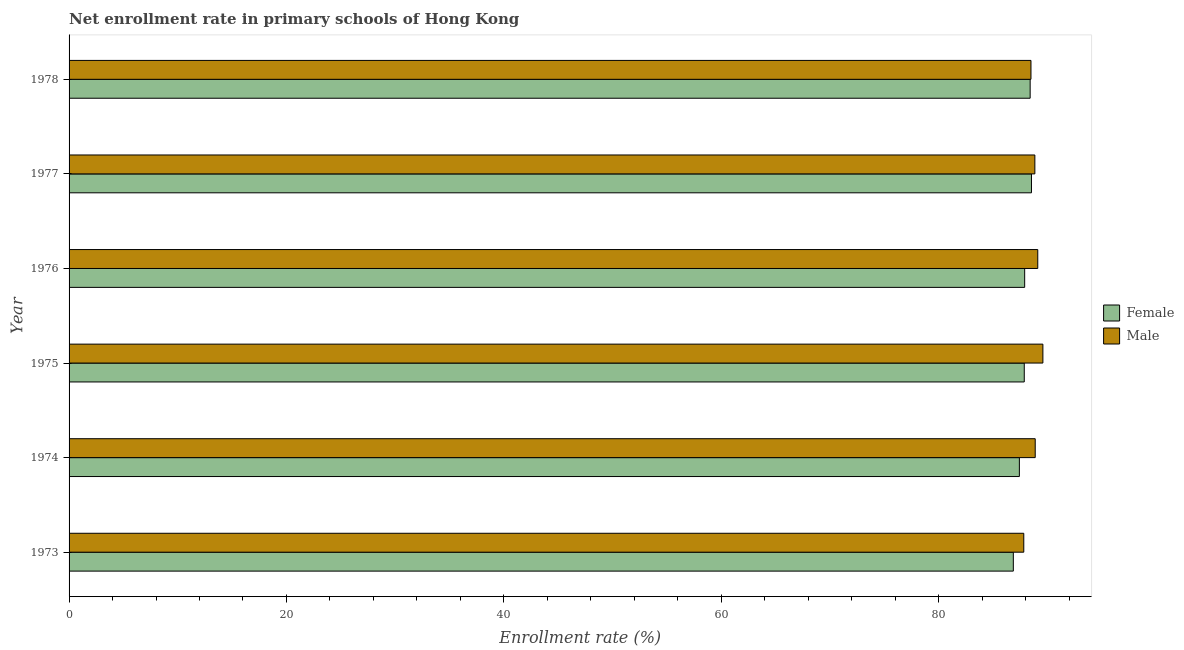How many different coloured bars are there?
Offer a very short reply. 2. How many groups of bars are there?
Give a very brief answer. 6. Are the number of bars per tick equal to the number of legend labels?
Your answer should be very brief. Yes. Are the number of bars on each tick of the Y-axis equal?
Your answer should be very brief. Yes. How many bars are there on the 6th tick from the top?
Offer a very short reply. 2. How many bars are there on the 2nd tick from the bottom?
Your answer should be very brief. 2. In how many cases, is the number of bars for a given year not equal to the number of legend labels?
Your response must be concise. 0. What is the enrollment rate of male students in 1973?
Ensure brevity in your answer.  87.83. Across all years, what is the maximum enrollment rate of female students?
Give a very brief answer. 88.54. Across all years, what is the minimum enrollment rate of female students?
Provide a short and direct response. 86.87. In which year was the enrollment rate of male students maximum?
Your response must be concise. 1975. What is the total enrollment rate of female students in the graph?
Give a very brief answer. 527.05. What is the difference between the enrollment rate of male students in 1974 and that in 1976?
Make the answer very short. -0.23. What is the difference between the enrollment rate of female students in 1975 and the enrollment rate of male students in 1978?
Provide a short and direct response. -0.62. What is the average enrollment rate of male students per year?
Your response must be concise. 88.8. Is the enrollment rate of male students in 1973 less than that in 1978?
Make the answer very short. Yes. What is the difference between the highest and the second highest enrollment rate of female students?
Your answer should be compact. 0.12. What is the difference between the highest and the lowest enrollment rate of male students?
Offer a terse response. 1.76. In how many years, is the enrollment rate of male students greater than the average enrollment rate of male students taken over all years?
Keep it short and to the point. 4. What does the 1st bar from the bottom in 1978 represents?
Offer a terse response. Female. Are all the bars in the graph horizontal?
Ensure brevity in your answer.  Yes. What is the difference between two consecutive major ticks on the X-axis?
Make the answer very short. 20. Are the values on the major ticks of X-axis written in scientific E-notation?
Your answer should be compact. No. Does the graph contain grids?
Provide a short and direct response. No. Where does the legend appear in the graph?
Provide a succinct answer. Center right. How many legend labels are there?
Your answer should be compact. 2. What is the title of the graph?
Provide a succinct answer. Net enrollment rate in primary schools of Hong Kong. What is the label or title of the X-axis?
Ensure brevity in your answer.  Enrollment rate (%). What is the label or title of the Y-axis?
Your response must be concise. Year. What is the Enrollment rate (%) in Female in 1973?
Provide a short and direct response. 86.87. What is the Enrollment rate (%) of Male in 1973?
Your response must be concise. 87.83. What is the Enrollment rate (%) in Female in 1974?
Provide a succinct answer. 87.43. What is the Enrollment rate (%) of Male in 1974?
Make the answer very short. 88.89. What is the Enrollment rate (%) of Female in 1975?
Your response must be concise. 87.88. What is the Enrollment rate (%) in Male in 1975?
Your answer should be very brief. 89.59. What is the Enrollment rate (%) in Female in 1976?
Give a very brief answer. 87.92. What is the Enrollment rate (%) of Male in 1976?
Give a very brief answer. 89.12. What is the Enrollment rate (%) in Female in 1977?
Your answer should be compact. 88.54. What is the Enrollment rate (%) of Male in 1977?
Offer a very short reply. 88.85. What is the Enrollment rate (%) in Female in 1978?
Your answer should be very brief. 88.42. What is the Enrollment rate (%) of Male in 1978?
Provide a short and direct response. 88.5. Across all years, what is the maximum Enrollment rate (%) of Female?
Give a very brief answer. 88.54. Across all years, what is the maximum Enrollment rate (%) in Male?
Make the answer very short. 89.59. Across all years, what is the minimum Enrollment rate (%) in Female?
Provide a succinct answer. 86.87. Across all years, what is the minimum Enrollment rate (%) in Male?
Keep it short and to the point. 87.83. What is the total Enrollment rate (%) of Female in the graph?
Provide a succinct answer. 527.05. What is the total Enrollment rate (%) of Male in the graph?
Offer a very short reply. 532.78. What is the difference between the Enrollment rate (%) in Female in 1973 and that in 1974?
Provide a succinct answer. -0.56. What is the difference between the Enrollment rate (%) in Male in 1973 and that in 1974?
Give a very brief answer. -1.05. What is the difference between the Enrollment rate (%) of Female in 1973 and that in 1975?
Your answer should be compact. -1.01. What is the difference between the Enrollment rate (%) in Male in 1973 and that in 1975?
Offer a very short reply. -1.76. What is the difference between the Enrollment rate (%) of Female in 1973 and that in 1976?
Provide a short and direct response. -1.04. What is the difference between the Enrollment rate (%) in Male in 1973 and that in 1976?
Provide a succinct answer. -1.29. What is the difference between the Enrollment rate (%) in Female in 1973 and that in 1977?
Provide a short and direct response. -1.67. What is the difference between the Enrollment rate (%) in Male in 1973 and that in 1977?
Offer a very short reply. -1.02. What is the difference between the Enrollment rate (%) in Female in 1973 and that in 1978?
Your answer should be compact. -1.55. What is the difference between the Enrollment rate (%) in Male in 1973 and that in 1978?
Make the answer very short. -0.66. What is the difference between the Enrollment rate (%) in Female in 1974 and that in 1975?
Your answer should be compact. -0.45. What is the difference between the Enrollment rate (%) of Male in 1974 and that in 1975?
Offer a terse response. -0.71. What is the difference between the Enrollment rate (%) of Female in 1974 and that in 1976?
Offer a terse response. -0.49. What is the difference between the Enrollment rate (%) in Male in 1974 and that in 1976?
Your answer should be very brief. -0.23. What is the difference between the Enrollment rate (%) in Female in 1974 and that in 1977?
Provide a succinct answer. -1.11. What is the difference between the Enrollment rate (%) of Male in 1974 and that in 1977?
Provide a short and direct response. 0.03. What is the difference between the Enrollment rate (%) of Female in 1974 and that in 1978?
Ensure brevity in your answer.  -0.99. What is the difference between the Enrollment rate (%) in Male in 1974 and that in 1978?
Your response must be concise. 0.39. What is the difference between the Enrollment rate (%) in Female in 1975 and that in 1976?
Your answer should be very brief. -0.04. What is the difference between the Enrollment rate (%) in Male in 1975 and that in 1976?
Your answer should be very brief. 0.47. What is the difference between the Enrollment rate (%) of Female in 1975 and that in 1977?
Ensure brevity in your answer.  -0.66. What is the difference between the Enrollment rate (%) of Male in 1975 and that in 1977?
Make the answer very short. 0.74. What is the difference between the Enrollment rate (%) in Female in 1975 and that in 1978?
Keep it short and to the point. -0.54. What is the difference between the Enrollment rate (%) of Male in 1975 and that in 1978?
Ensure brevity in your answer.  1.1. What is the difference between the Enrollment rate (%) of Female in 1976 and that in 1977?
Offer a terse response. -0.63. What is the difference between the Enrollment rate (%) in Male in 1976 and that in 1977?
Offer a terse response. 0.27. What is the difference between the Enrollment rate (%) in Female in 1976 and that in 1978?
Your response must be concise. -0.5. What is the difference between the Enrollment rate (%) in Male in 1976 and that in 1978?
Ensure brevity in your answer.  0.62. What is the difference between the Enrollment rate (%) of Female in 1977 and that in 1978?
Provide a short and direct response. 0.12. What is the difference between the Enrollment rate (%) of Male in 1977 and that in 1978?
Give a very brief answer. 0.36. What is the difference between the Enrollment rate (%) in Female in 1973 and the Enrollment rate (%) in Male in 1974?
Provide a succinct answer. -2.01. What is the difference between the Enrollment rate (%) in Female in 1973 and the Enrollment rate (%) in Male in 1975?
Your answer should be very brief. -2.72. What is the difference between the Enrollment rate (%) in Female in 1973 and the Enrollment rate (%) in Male in 1976?
Your answer should be compact. -2.25. What is the difference between the Enrollment rate (%) in Female in 1973 and the Enrollment rate (%) in Male in 1977?
Provide a short and direct response. -1.98. What is the difference between the Enrollment rate (%) of Female in 1973 and the Enrollment rate (%) of Male in 1978?
Offer a very short reply. -1.62. What is the difference between the Enrollment rate (%) in Female in 1974 and the Enrollment rate (%) in Male in 1975?
Your answer should be compact. -2.16. What is the difference between the Enrollment rate (%) of Female in 1974 and the Enrollment rate (%) of Male in 1976?
Your response must be concise. -1.69. What is the difference between the Enrollment rate (%) of Female in 1974 and the Enrollment rate (%) of Male in 1977?
Ensure brevity in your answer.  -1.42. What is the difference between the Enrollment rate (%) of Female in 1974 and the Enrollment rate (%) of Male in 1978?
Give a very brief answer. -1.07. What is the difference between the Enrollment rate (%) of Female in 1975 and the Enrollment rate (%) of Male in 1976?
Offer a terse response. -1.24. What is the difference between the Enrollment rate (%) of Female in 1975 and the Enrollment rate (%) of Male in 1977?
Make the answer very short. -0.97. What is the difference between the Enrollment rate (%) in Female in 1975 and the Enrollment rate (%) in Male in 1978?
Offer a very short reply. -0.62. What is the difference between the Enrollment rate (%) of Female in 1976 and the Enrollment rate (%) of Male in 1977?
Your answer should be compact. -0.94. What is the difference between the Enrollment rate (%) of Female in 1976 and the Enrollment rate (%) of Male in 1978?
Provide a succinct answer. -0.58. What is the difference between the Enrollment rate (%) of Female in 1977 and the Enrollment rate (%) of Male in 1978?
Your response must be concise. 0.05. What is the average Enrollment rate (%) of Female per year?
Keep it short and to the point. 87.84. What is the average Enrollment rate (%) of Male per year?
Your answer should be very brief. 88.8. In the year 1973, what is the difference between the Enrollment rate (%) of Female and Enrollment rate (%) of Male?
Make the answer very short. -0.96. In the year 1974, what is the difference between the Enrollment rate (%) in Female and Enrollment rate (%) in Male?
Ensure brevity in your answer.  -1.46. In the year 1975, what is the difference between the Enrollment rate (%) of Female and Enrollment rate (%) of Male?
Give a very brief answer. -1.71. In the year 1976, what is the difference between the Enrollment rate (%) in Female and Enrollment rate (%) in Male?
Your answer should be very brief. -1.2. In the year 1977, what is the difference between the Enrollment rate (%) in Female and Enrollment rate (%) in Male?
Keep it short and to the point. -0.31. In the year 1978, what is the difference between the Enrollment rate (%) of Female and Enrollment rate (%) of Male?
Your answer should be very brief. -0.08. What is the ratio of the Enrollment rate (%) of Female in 1973 to that in 1974?
Offer a very short reply. 0.99. What is the ratio of the Enrollment rate (%) of Male in 1973 to that in 1974?
Provide a succinct answer. 0.99. What is the ratio of the Enrollment rate (%) in Female in 1973 to that in 1975?
Your response must be concise. 0.99. What is the ratio of the Enrollment rate (%) of Male in 1973 to that in 1975?
Give a very brief answer. 0.98. What is the ratio of the Enrollment rate (%) in Male in 1973 to that in 1976?
Give a very brief answer. 0.99. What is the ratio of the Enrollment rate (%) of Female in 1973 to that in 1977?
Your answer should be very brief. 0.98. What is the ratio of the Enrollment rate (%) in Female in 1973 to that in 1978?
Your answer should be compact. 0.98. What is the ratio of the Enrollment rate (%) in Male in 1974 to that in 1975?
Offer a very short reply. 0.99. What is the ratio of the Enrollment rate (%) of Male in 1974 to that in 1976?
Offer a terse response. 1. What is the ratio of the Enrollment rate (%) in Female in 1974 to that in 1977?
Offer a terse response. 0.99. What is the ratio of the Enrollment rate (%) of Male in 1975 to that in 1976?
Your answer should be very brief. 1.01. What is the ratio of the Enrollment rate (%) in Male in 1975 to that in 1977?
Provide a short and direct response. 1.01. What is the ratio of the Enrollment rate (%) of Male in 1975 to that in 1978?
Provide a short and direct response. 1.01. What is the ratio of the Enrollment rate (%) in Female in 1976 to that in 1977?
Keep it short and to the point. 0.99. What is the ratio of the Enrollment rate (%) of Male in 1976 to that in 1978?
Your response must be concise. 1.01. What is the difference between the highest and the second highest Enrollment rate (%) in Female?
Provide a succinct answer. 0.12. What is the difference between the highest and the second highest Enrollment rate (%) in Male?
Provide a succinct answer. 0.47. What is the difference between the highest and the lowest Enrollment rate (%) of Female?
Offer a very short reply. 1.67. What is the difference between the highest and the lowest Enrollment rate (%) of Male?
Offer a very short reply. 1.76. 